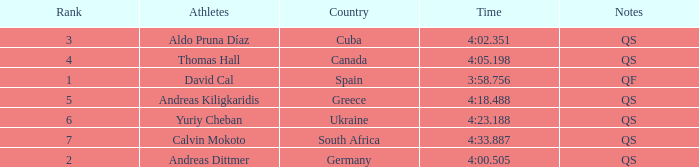What is Calvin Mokoto's average rank? 7.0. 